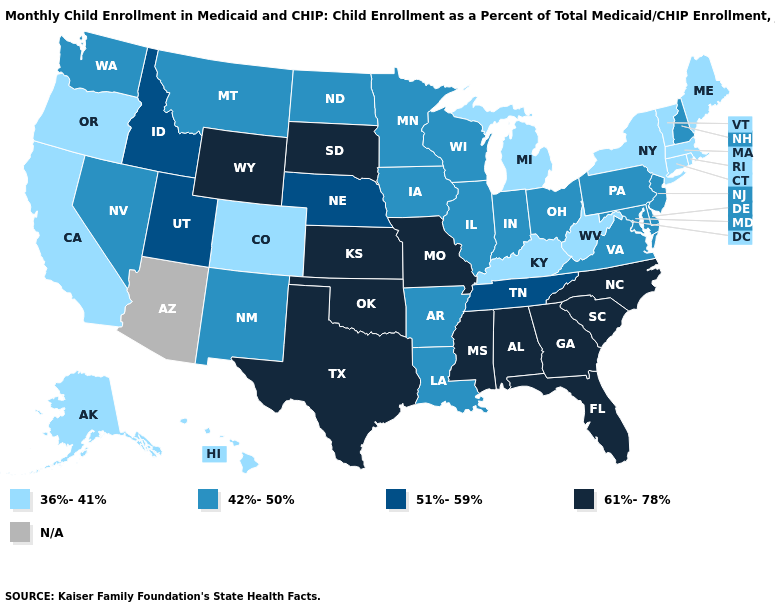Name the states that have a value in the range 61%-78%?
Keep it brief. Alabama, Florida, Georgia, Kansas, Mississippi, Missouri, North Carolina, Oklahoma, South Carolina, South Dakota, Texas, Wyoming. Name the states that have a value in the range 51%-59%?
Keep it brief. Idaho, Nebraska, Tennessee, Utah. What is the value of Missouri?
Keep it brief. 61%-78%. What is the value of Iowa?
Give a very brief answer. 42%-50%. What is the lowest value in the USA?
Short answer required. 36%-41%. Does the map have missing data?
Concise answer only. Yes. What is the highest value in states that border Mississippi?
Concise answer only. 61%-78%. How many symbols are there in the legend?
Short answer required. 5. Name the states that have a value in the range 36%-41%?
Concise answer only. Alaska, California, Colorado, Connecticut, Hawaii, Kentucky, Maine, Massachusetts, Michigan, New York, Oregon, Rhode Island, Vermont, West Virginia. What is the lowest value in states that border New Jersey?
Concise answer only. 36%-41%. What is the value of Rhode Island?
Write a very short answer. 36%-41%. Which states have the lowest value in the USA?
Be succinct. Alaska, California, Colorado, Connecticut, Hawaii, Kentucky, Maine, Massachusetts, Michigan, New York, Oregon, Rhode Island, Vermont, West Virginia. Which states have the lowest value in the Northeast?
Keep it brief. Connecticut, Maine, Massachusetts, New York, Rhode Island, Vermont. Name the states that have a value in the range 36%-41%?
Concise answer only. Alaska, California, Colorado, Connecticut, Hawaii, Kentucky, Maine, Massachusetts, Michigan, New York, Oregon, Rhode Island, Vermont, West Virginia. Does Connecticut have the lowest value in the Northeast?
Short answer required. Yes. 